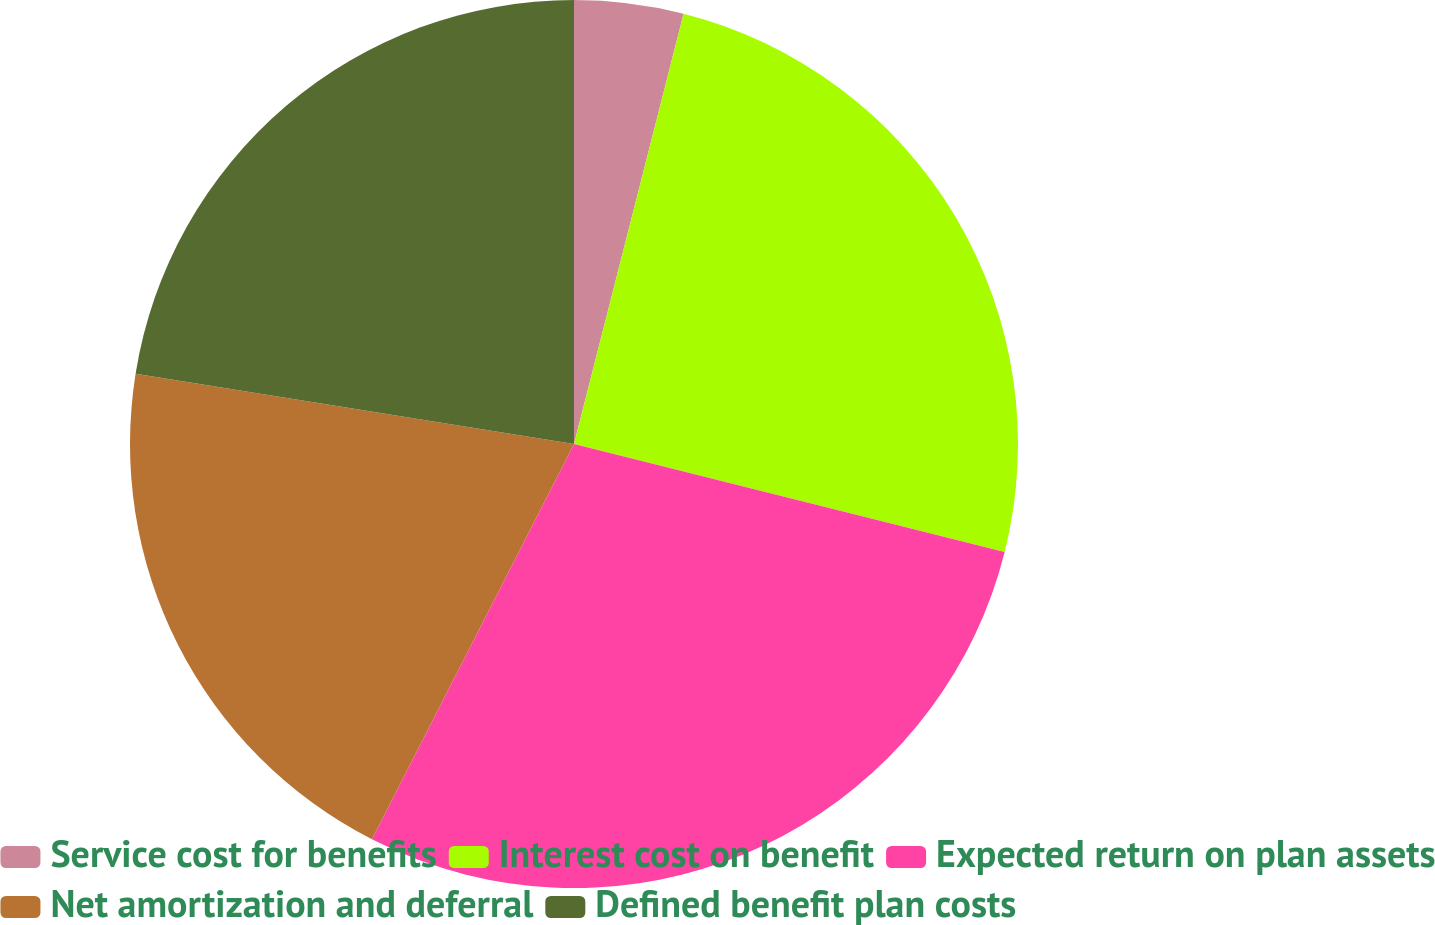Convert chart. <chart><loc_0><loc_0><loc_500><loc_500><pie_chart><fcel>Service cost for benefits<fcel>Interest cost on benefit<fcel>Expected return on plan assets<fcel>Net amortization and deferral<fcel>Defined benefit plan costs<nl><fcel>3.97%<fcel>24.94%<fcel>28.61%<fcel>20.01%<fcel>22.47%<nl></chart> 